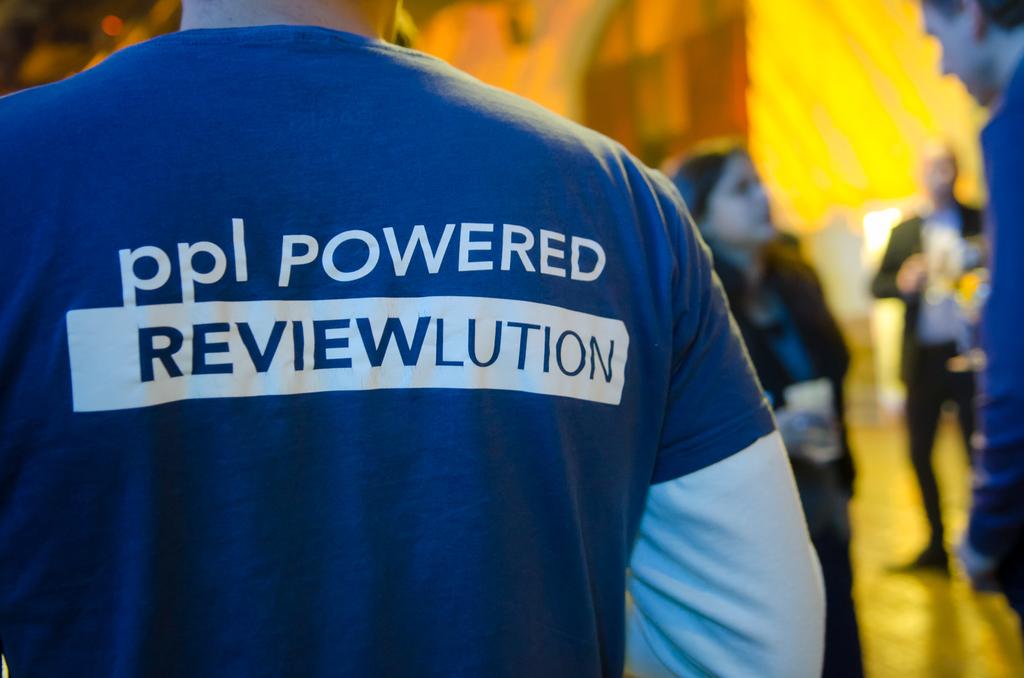Is it powered by people?
Your answer should be compact. Yes. Whats the advert about?
Provide a short and direct response. Ppl powered reviewlution. 